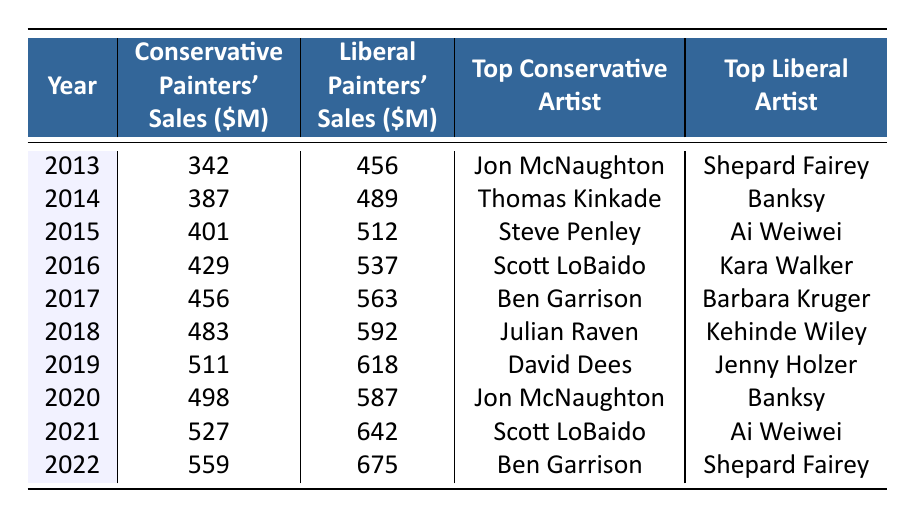What was the total sales for conservative painters in 2019? In 2019, the sales for conservative painters are listed as 511 million dollars.
Answer: 511 million dollars What year had the highest sales for liberal painters? By comparing all the years, 2022 has the highest sales for liberal painters at 675 million dollars.
Answer: 2022 What is the difference in sales between conservative and liberal painters in 2020? In 2020, conservative painters' sales were 498 million dollars while liberal painters' sales were 587 million dollars. The difference is 587 - 498 = 89 million dollars.
Answer: 89 million dollars Which conservative artist achieved the highest sales in 2021? In 2021, the table indicates that Scott LoBaido was the top conservative artist.
Answer: Scott LoBaido What was the average sales for conservative painters over the last decade? The total sales for conservative painters from 2013 to 2022 are 342 + 387 + 401 + 429 + 456 + 483 + 511 + 498 + 527 + 559 = 4493 million dollars. There are 10 years, so the average is 4493 / 10 = 449.3 million dollars.
Answer: 449.3 million dollars Did liberal painters ever achieve higher sales than conservative painters in every year? By reviewing the table, we see that in every year listed, liberal painters had higher sales than conservative painters. Therefore, the answer is yes.
Answer: Yes Which conservative artist was the top artist in the year with the highest overall sales for liberal painters? The highest overall sales for liberal painters were in 2022 with 675 million dollars. The top conservative artist that year was Ben Garrison.
Answer: Ben Garrison What was the trend in conservative painters' sales from 2013 to 2022? The table shows a consistent increase in conservative painters' sales from 342 million dollars in 2013 to 559 million dollars in 2022, indicating a positive growth trend across the years.
Answer: Positive growth trend What was the combined sales for both conservative and liberal painters in 2014? In 2014, conservative sales were 387 million dollars and liberal sales were 489 million dollars. Combined, that totals 387 + 489 = 876 million dollars.
Answer: 876 million dollars How many years did Ben Garrison rank as the top conservative artist? By checking the entries, Ben Garrison is listed as the top conservative artist in 2017 and 2022, which makes it two years.
Answer: 2 years 